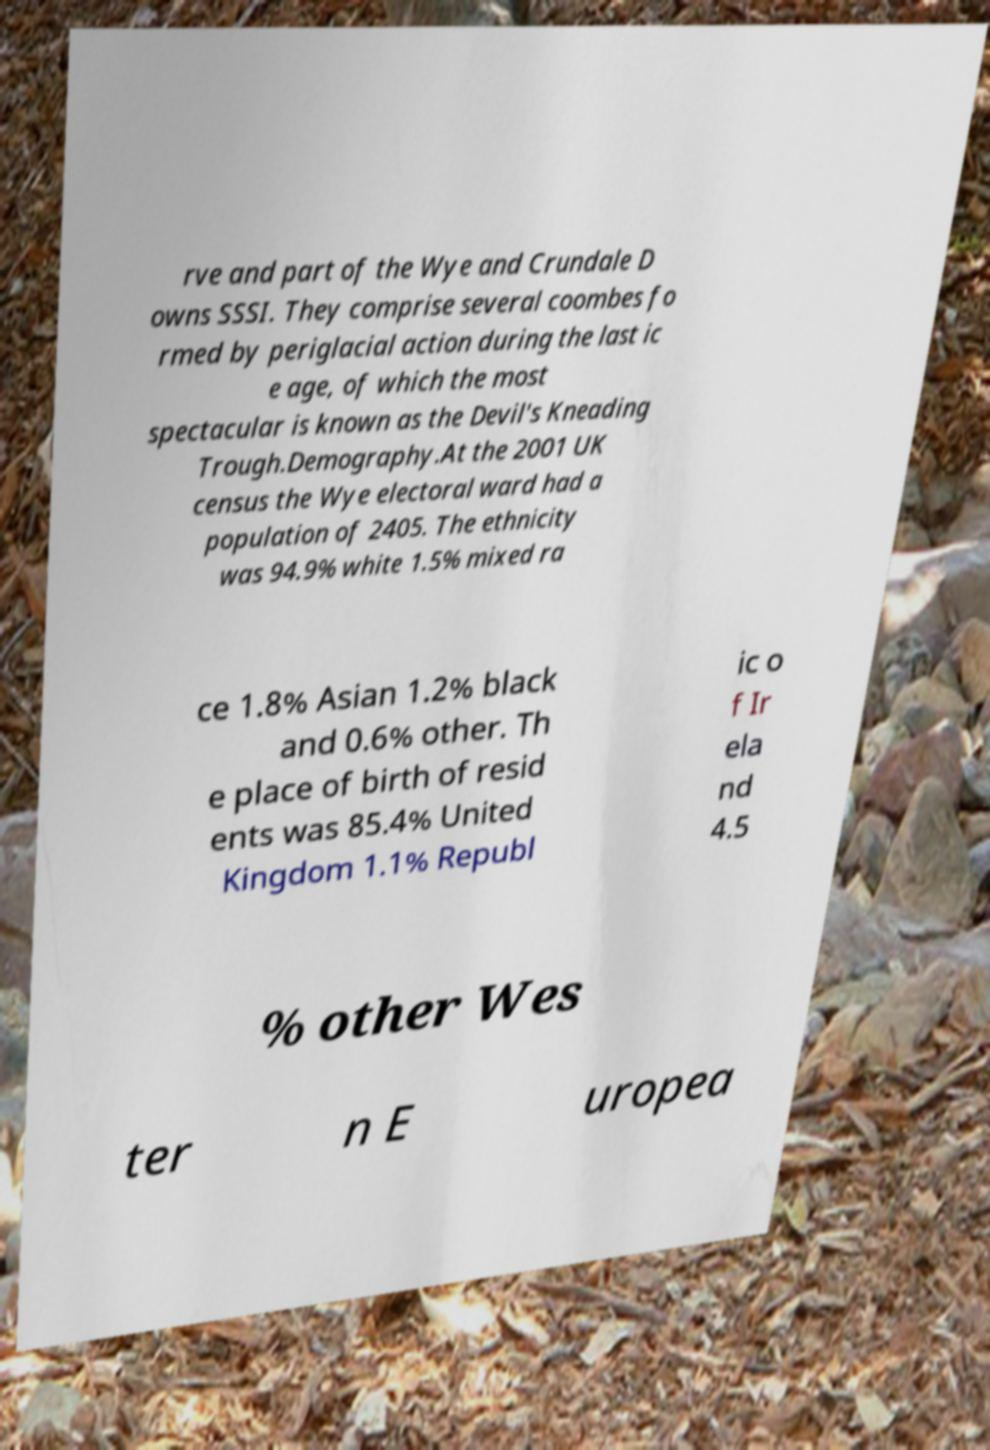Please identify and transcribe the text found in this image. rve and part of the Wye and Crundale D owns SSSI. They comprise several coombes fo rmed by periglacial action during the last ic e age, of which the most spectacular is known as the Devil's Kneading Trough.Demography.At the 2001 UK census the Wye electoral ward had a population of 2405. The ethnicity was 94.9% white 1.5% mixed ra ce 1.8% Asian 1.2% black and 0.6% other. Th e place of birth of resid ents was 85.4% United Kingdom 1.1% Republ ic o f Ir ela nd 4.5 % other Wes ter n E uropea 